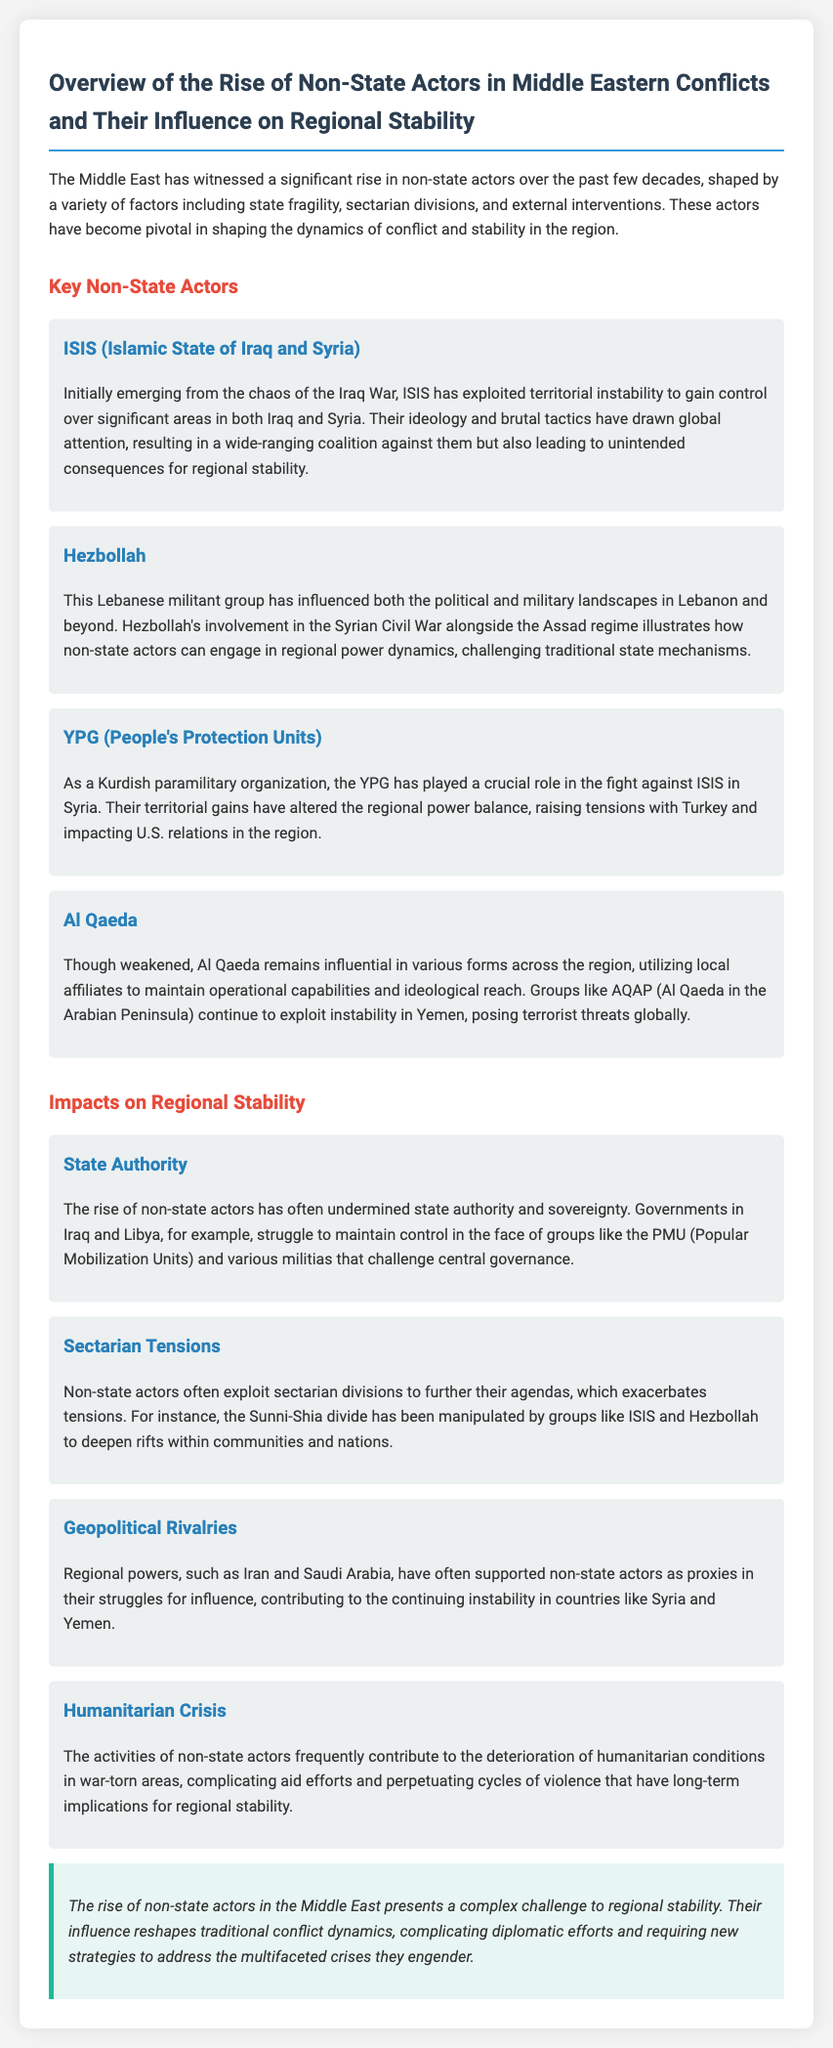What is the title of the document? The title is found at the beginning of the document, indicating its main focus on non-state actors and regional stability.
Answer: Overview of the Rise of Non-State Actors in Middle Eastern Conflicts and Their Influence on Regional Stability Who is the main militant group mentioned as originating from the chaos of the Iraq War? This information can be found in the section dedicated to key non-state actors, describing ISIS and its background.
Answer: ISIS (Islamic State of Iraq and Syria) Which group has influenced the political and military landscapes in Lebanon? The document highlights Hezbollah's role, specifying its influence in Lebanon and beyond in the relevant section.
Answer: Hezbollah What do non-state actors often exploit to further their agendas? The document explains that sectarian divisions are commonly exploited by non-state actors, as indicated in the impacts on regional stability.
Answer: Sectarian divisions Which region's powers have supported non-state actors as proxies? The text points out that Iran and Saudi Arabia's support for non-state actors relates to their geopolitical rivalries.
Answer: Regional powers What has been a significant consequence of non-state actors on humanitarian conditions? The document details how the activities of non-state actors contribute to the deterioration of humanitarian conditions, complicating aid efforts.
Answer: Humanitarian crisis How do non-state actors challenge central governance in some countries? The document states that the rise of non-state actors has undermined state authority, providing an example with Iraq and Libya.
Answer: Undermined state authority What ideological divide has been manipulated by groups like ISIS and Hezbollah? The document indicates the Sunni-Shia divide has been exploited by these groups, contributing to increased tensions.
Answer: Sunni-Shia divide What role has the YPG played in the fight against ISIS? Details in the document specifically mention the YPG's crucial role in combating ISIS within Syria.
Answer: Fight against ISIS 